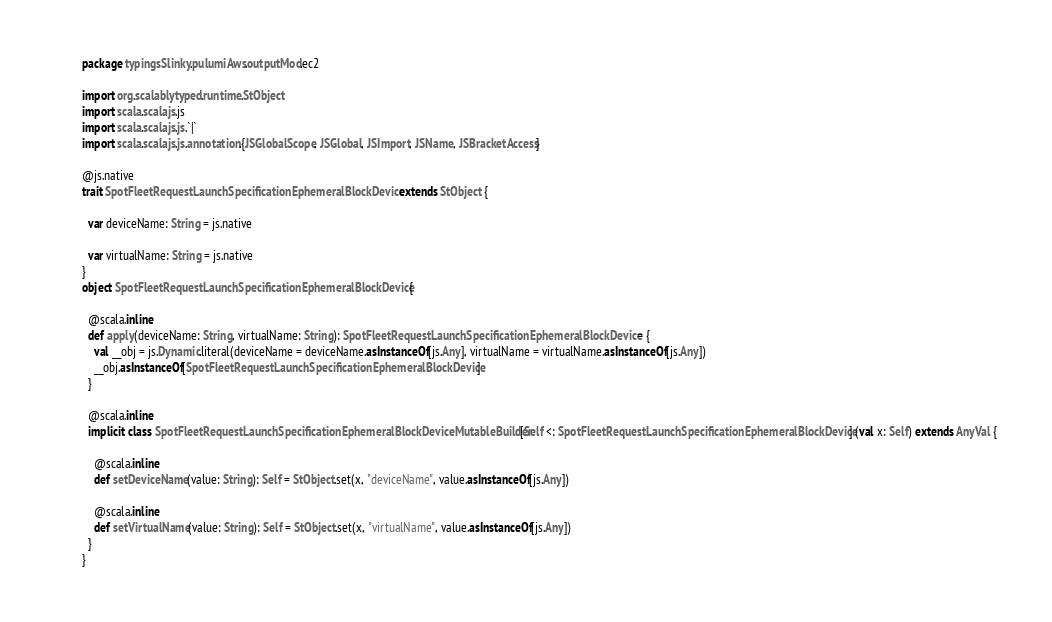<code> <loc_0><loc_0><loc_500><loc_500><_Scala_>package typingsSlinky.pulumiAws.outputMod.ec2

import org.scalablytyped.runtime.StObject
import scala.scalajs.js
import scala.scalajs.js.`|`
import scala.scalajs.js.annotation.{JSGlobalScope, JSGlobal, JSImport, JSName, JSBracketAccess}

@js.native
trait SpotFleetRequestLaunchSpecificationEphemeralBlockDevice extends StObject {
  
  var deviceName: String = js.native
  
  var virtualName: String = js.native
}
object SpotFleetRequestLaunchSpecificationEphemeralBlockDevice {
  
  @scala.inline
  def apply(deviceName: String, virtualName: String): SpotFleetRequestLaunchSpecificationEphemeralBlockDevice = {
    val __obj = js.Dynamic.literal(deviceName = deviceName.asInstanceOf[js.Any], virtualName = virtualName.asInstanceOf[js.Any])
    __obj.asInstanceOf[SpotFleetRequestLaunchSpecificationEphemeralBlockDevice]
  }
  
  @scala.inline
  implicit class SpotFleetRequestLaunchSpecificationEphemeralBlockDeviceMutableBuilder[Self <: SpotFleetRequestLaunchSpecificationEphemeralBlockDevice] (val x: Self) extends AnyVal {
    
    @scala.inline
    def setDeviceName(value: String): Self = StObject.set(x, "deviceName", value.asInstanceOf[js.Any])
    
    @scala.inline
    def setVirtualName(value: String): Self = StObject.set(x, "virtualName", value.asInstanceOf[js.Any])
  }
}
</code> 